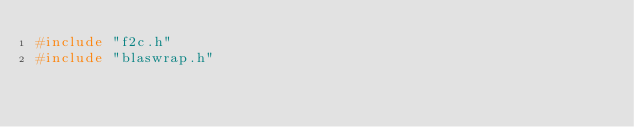<code> <loc_0><loc_0><loc_500><loc_500><_C_>#include "f2c.h"
#include "blaswrap.h"
</code> 